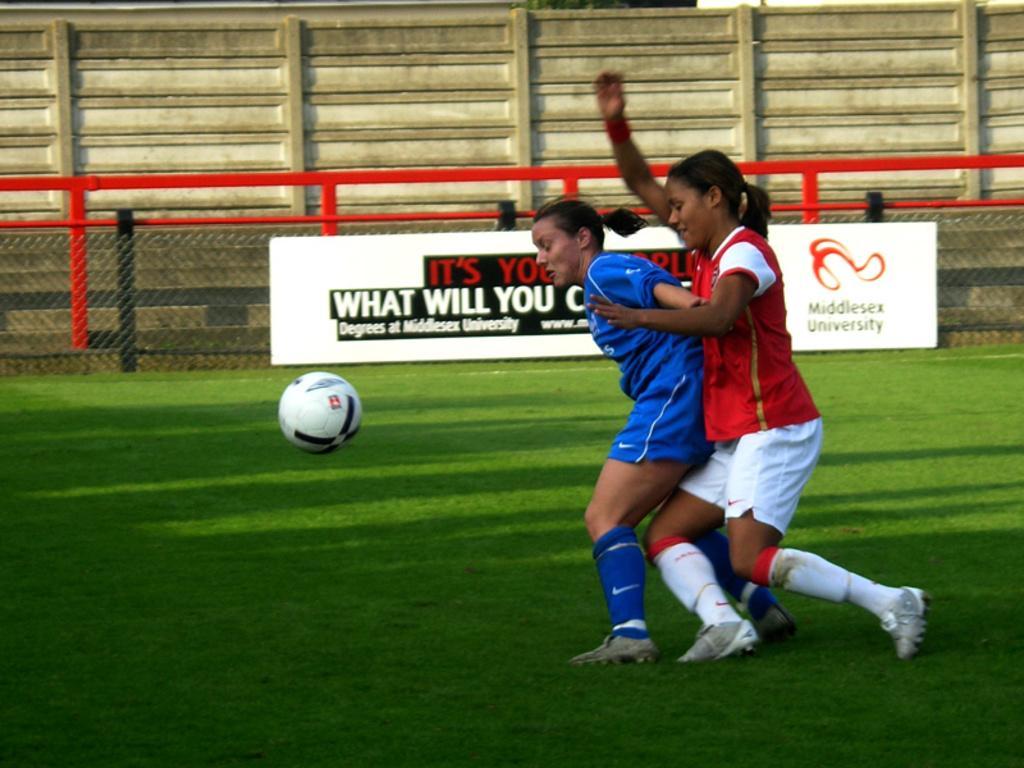Please provide a concise description of this image. In this image there are two women who are playing football, at the bottom there is grass and in the background there is a wall, fence and a board. 